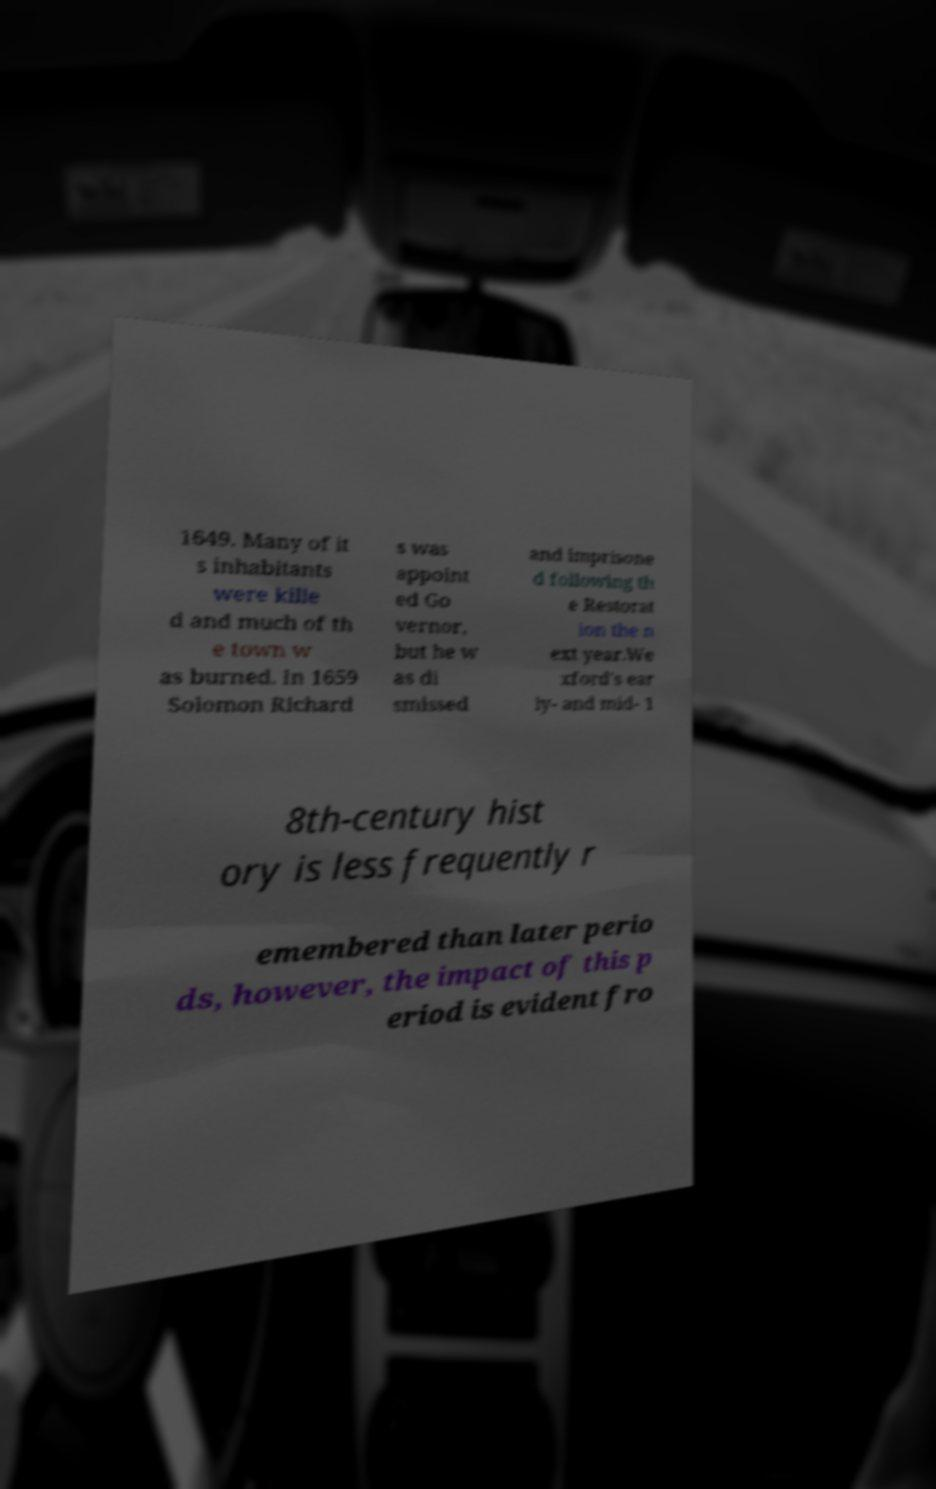Could you extract and type out the text from this image? 1649. Many of it s inhabitants were kille d and much of th e town w as burned. In 1659 Solomon Richard s was appoint ed Go vernor, but he w as di smissed and imprisone d following th e Restorat ion the n ext year.We xford's ear ly- and mid- 1 8th-century hist ory is less frequently r emembered than later perio ds, however, the impact of this p eriod is evident fro 